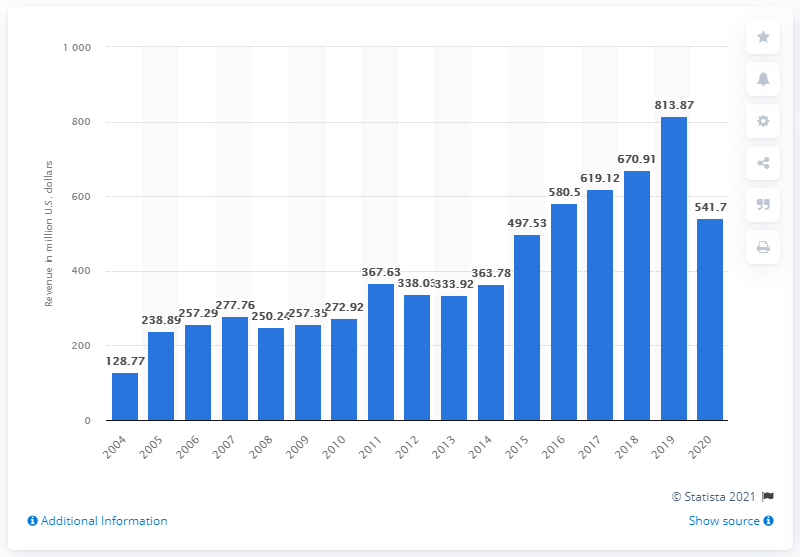Point out several critical features in this image. In 2020, PSA Airlines' operating revenue was 541.7 million dollars. 